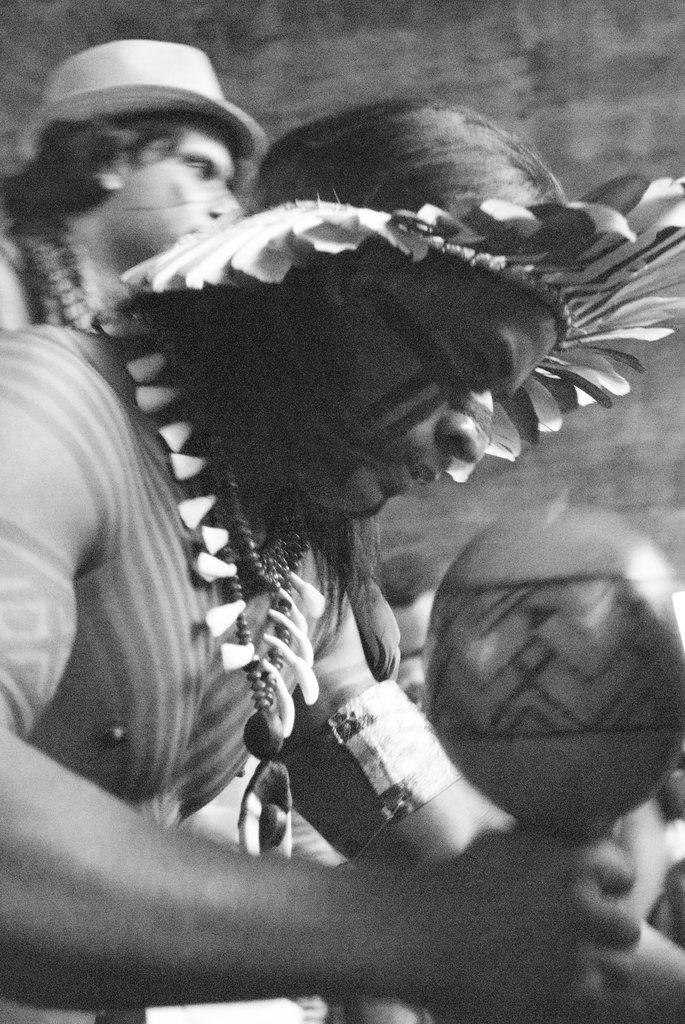In one or two sentences, can you explain what this image depicts? In this image we can see tribals. The man in the center is holding an object. In the background there is a wall. 